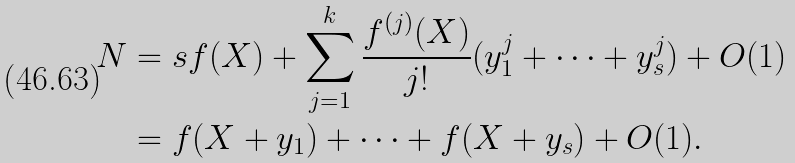<formula> <loc_0><loc_0><loc_500><loc_500>N & = s f ( X ) + \sum _ { j = 1 } ^ { k } \frac { f ^ { ( j ) } ( X ) } { j ! } ( y _ { 1 } ^ { j } + \dots + y _ { s } ^ { j } ) + O ( 1 ) \\ & = f ( X + y _ { 1 } ) + \dots + f ( X + y _ { s } ) + O ( 1 ) .</formula> 